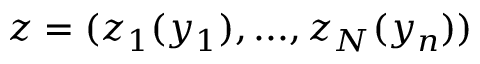<formula> <loc_0><loc_0><loc_500><loc_500>z = ( z _ { 1 } ( y _ { 1 } ) , \dots , z _ { N } ( y _ { n } ) )</formula> 